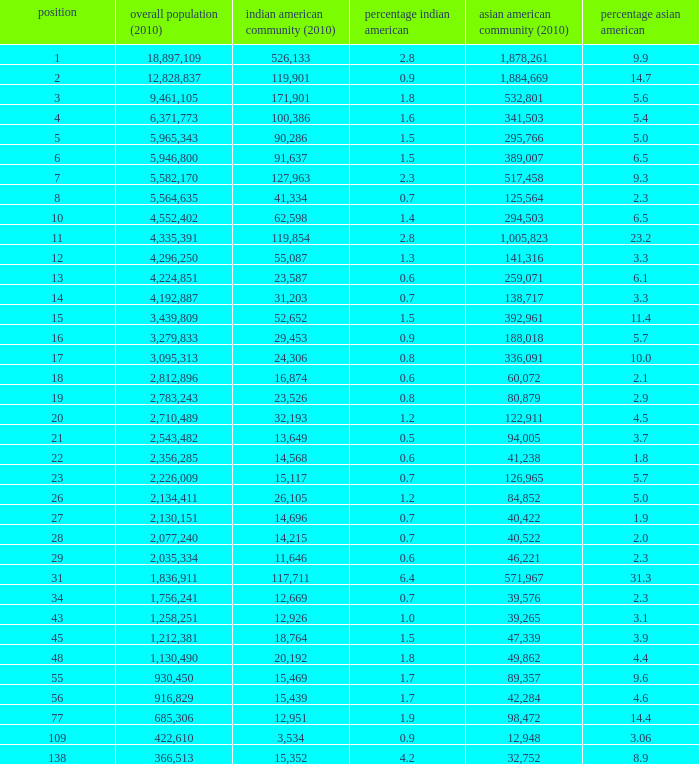What's the total population when the Asian American population is less than 60,072, the Indian American population is more than 14,696 and is 4.2% Indian American? 366513.0. 